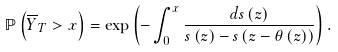<formula> <loc_0><loc_0><loc_500><loc_500>\mathbb { P } \left ( \overline { Y } _ { T } > x \right ) = \exp \left ( - \int _ { 0 } ^ { x } \frac { d s \left ( z \right ) } { s \left ( z \right ) - s \left ( z - \theta \left ( z \right ) \right ) } \right ) .</formula> 